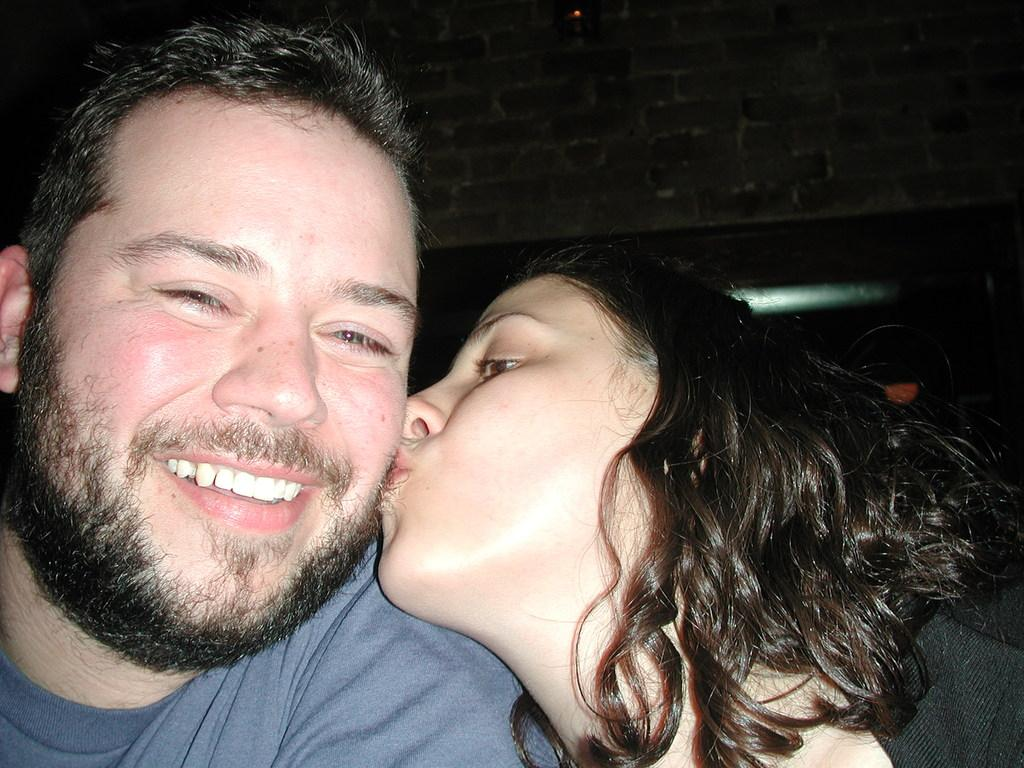Who is present in the image? There is a woman in the image. What is the woman doing in the image? The woman is kissing a man. How does the man appear to feel about the kiss? The man is smiling, which suggests he is happy or enjoying the moment. What can be seen in the background of the image? There is a brick wall and lights visible in the background of the image. How many deer can be seen in the image? There are no deer present in the image. What is the woman's desire in the image? The image does not provide information about the woman's desires or intentions. 